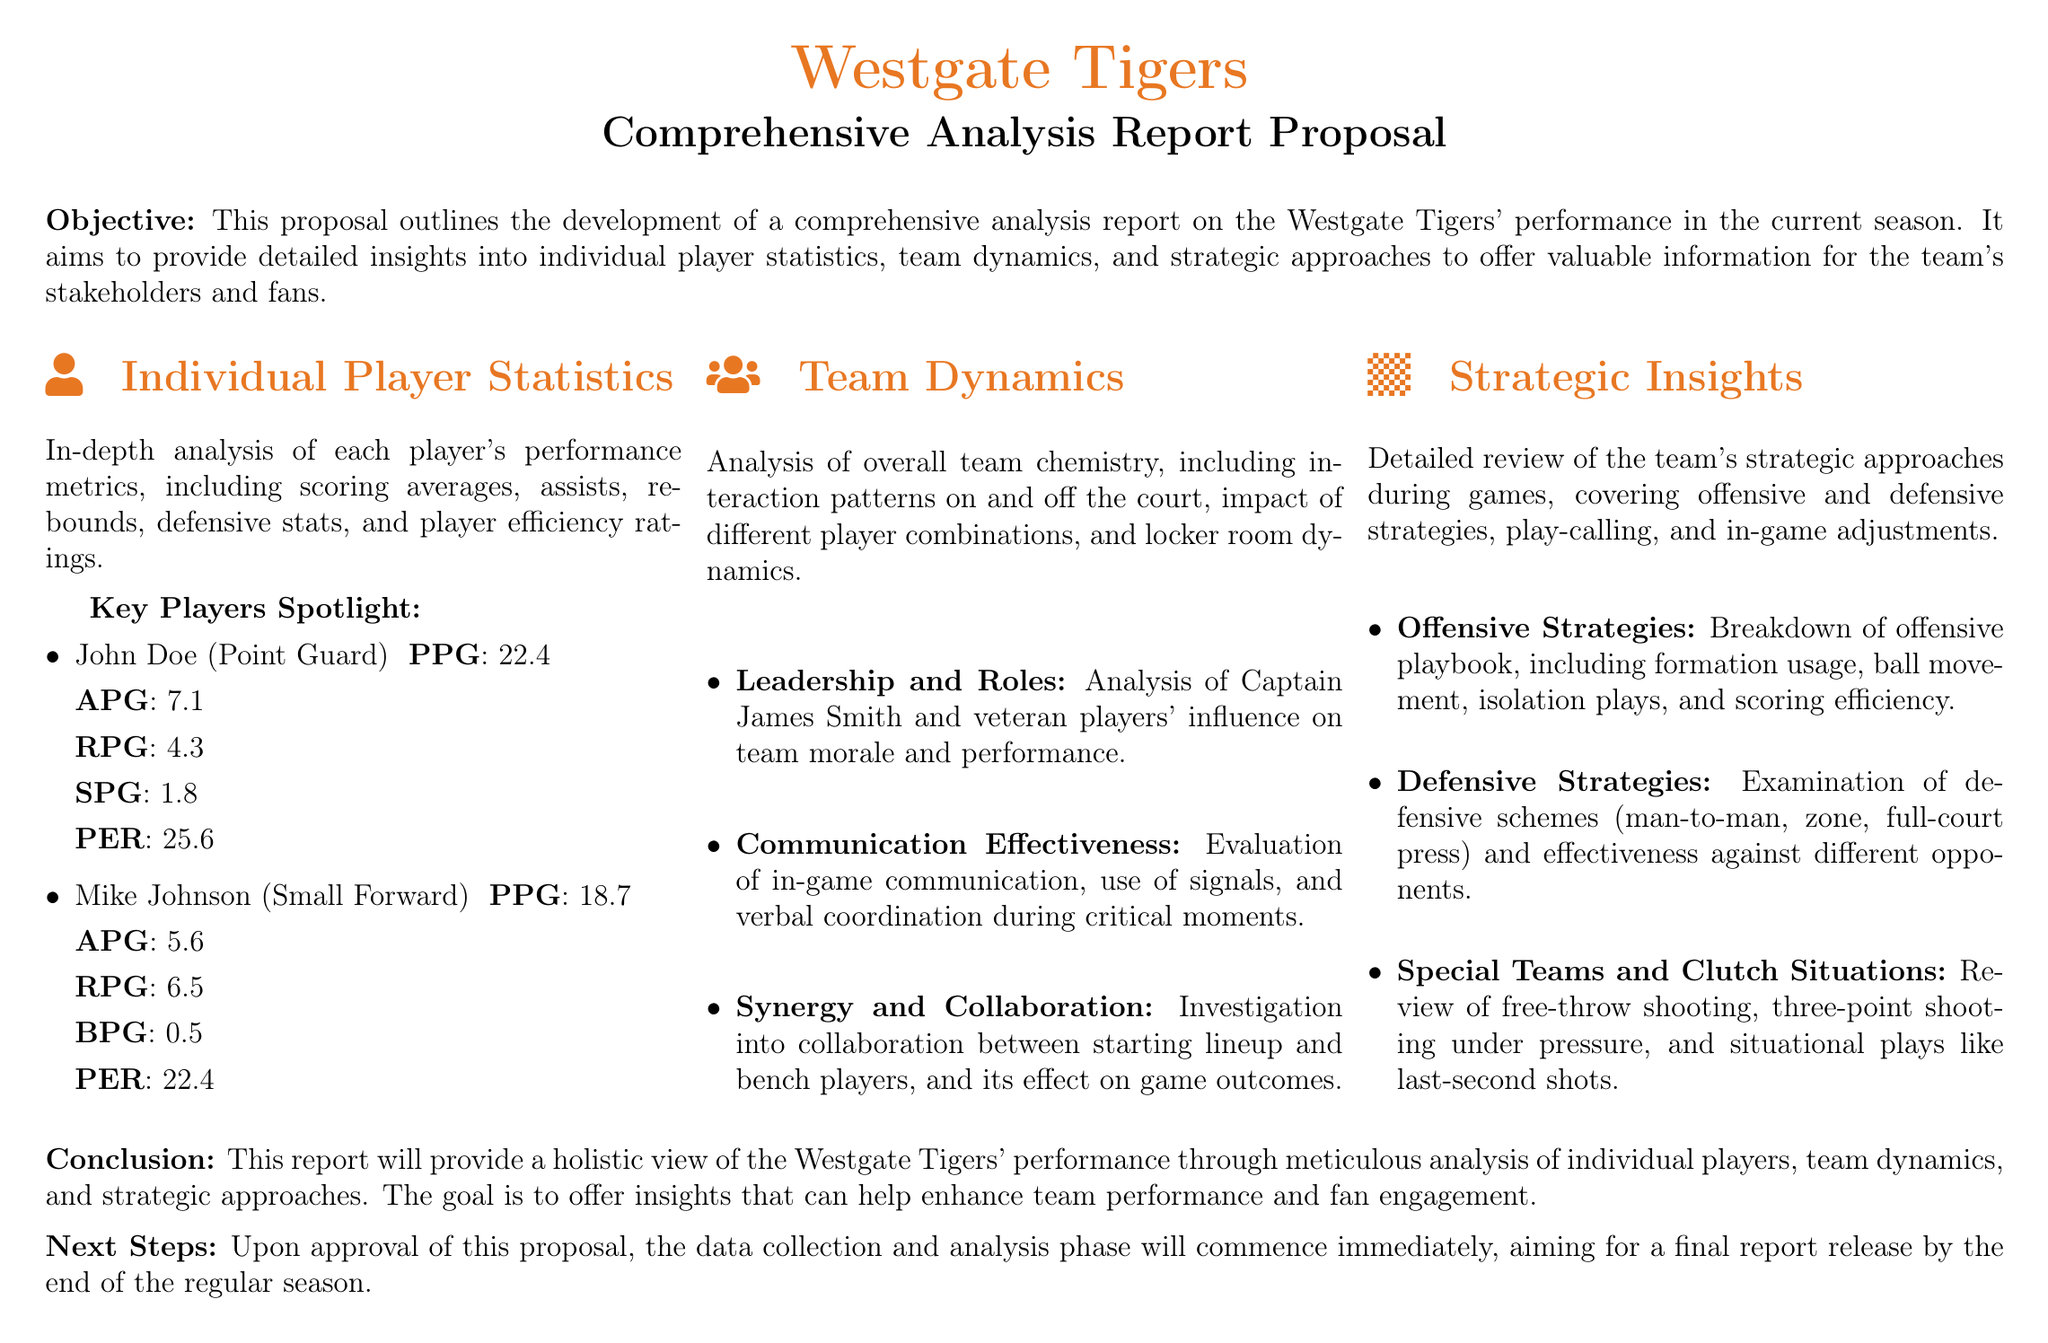What is the objective of the proposal? The objective is to outline the development of a comprehensive analysis report on the Westgate Tigers' performance in the current season.
Answer: Development of a comprehensive analysis report Who is highlighted as the captain of the team? The captain mentioned in the document is James Smith.
Answer: James Smith What is John Doe's points per game average? John Doe's scoring average is stated to be 22.4 points per game.
Answer: 22.4 What type of strategies are covered in the strategic insights section? The strategic insights cover both offensive and defensive strategies during games.
Answer: Offensive and defensive strategies What is the expected release date of the final report? The proposal mentions aiming for a final report release by the end of the regular season.
Answer: End of the regular season Which player position is Mike Johnson associated with? Mike Johnson is identified as a Small Forward in the document.
Answer: Small Forward What is included in the analysis of team dynamics? The analysis of team dynamics includes interaction patterns on and off the court.
Answer: Interaction patterns on and off the court What is the focus of the conclusion in the document? The conclusion focuses on providing a holistic view of the Westgate Tigers' performance through meticulous analysis.
Answer: Holistic view of performance 